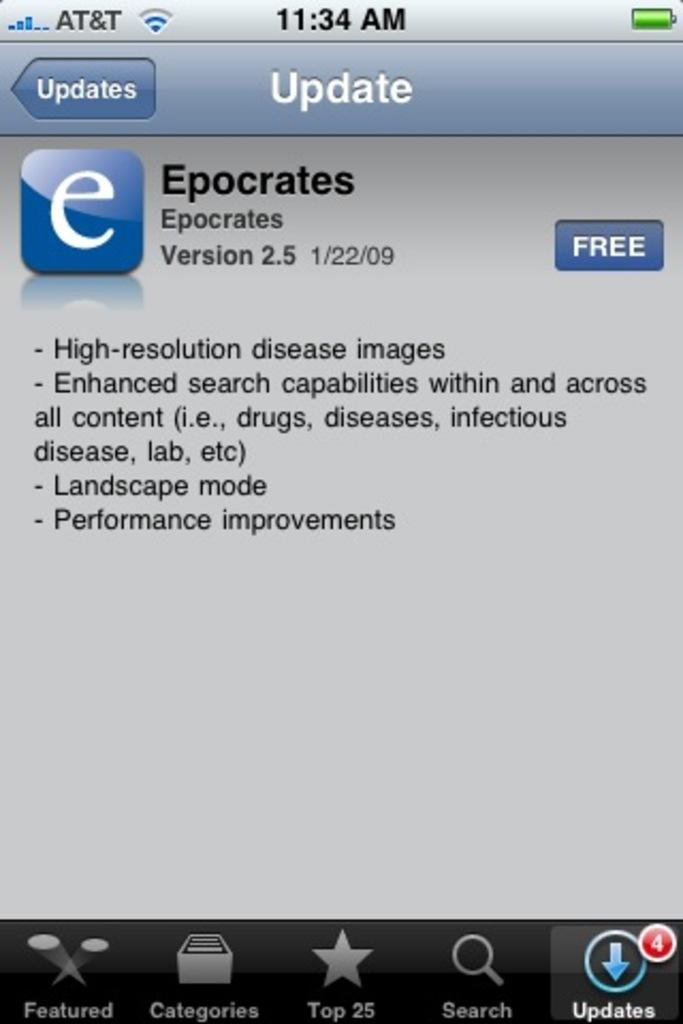<image>
Give a short and clear explanation of the subsequent image. A screenshot of a cell phone shows a free update for Epocrates Version 2.5. 